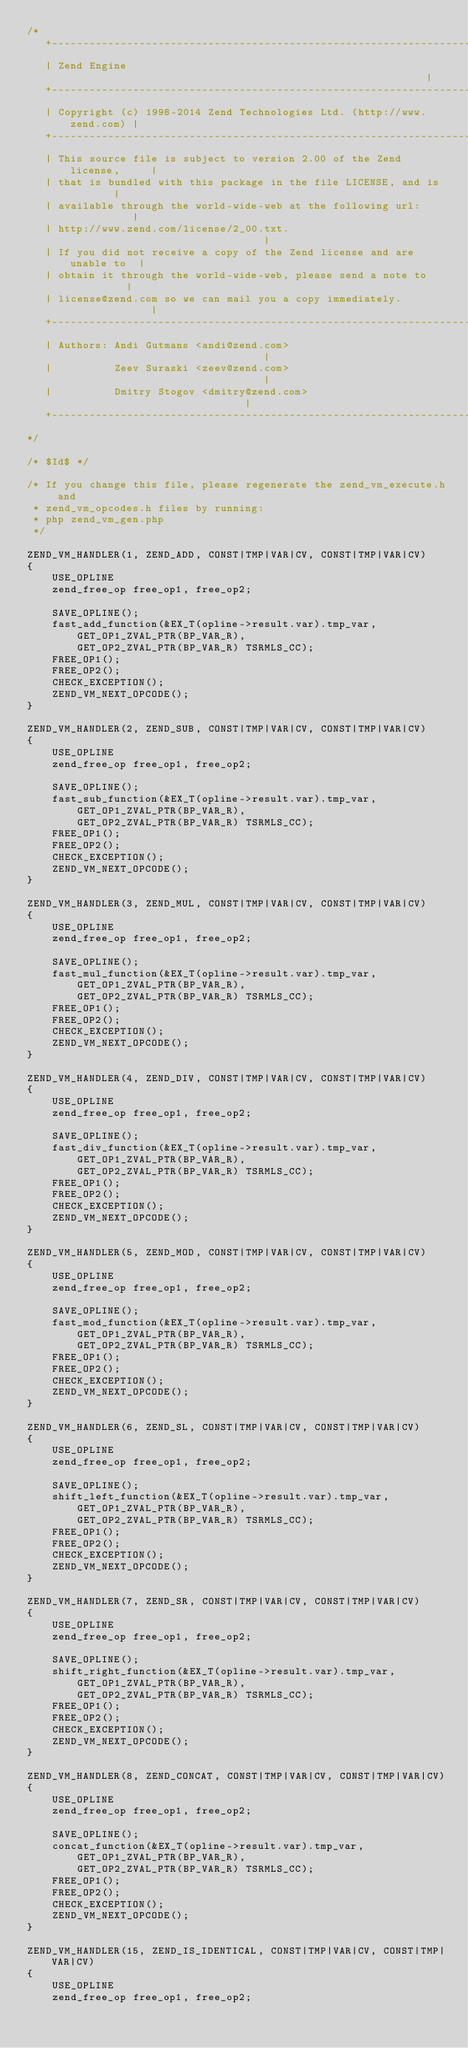<code> <loc_0><loc_0><loc_500><loc_500><_C_>/*
   +----------------------------------------------------------------------+
   | Zend Engine                                                          |
   +----------------------------------------------------------------------+
   | Copyright (c) 1998-2014 Zend Technologies Ltd. (http://www.zend.com) |
   +----------------------------------------------------------------------+
   | This source file is subject to version 2.00 of the Zend license,     |
   | that is bundled with this package in the file LICENSE, and is        |
   | available through the world-wide-web at the following url:           |
   | http://www.zend.com/license/2_00.txt.                                |
   | If you did not receive a copy of the Zend license and are unable to  |
   | obtain it through the world-wide-web, please send a note to          |
   | license@zend.com so we can mail you a copy immediately.              |
   +----------------------------------------------------------------------+
   | Authors: Andi Gutmans <andi@zend.com>                                |
   |          Zeev Suraski <zeev@zend.com>                                |
   |          Dmitry Stogov <dmitry@zend.com>                             |
   +----------------------------------------------------------------------+
*/

/* $Id$ */

/* If you change this file, please regenerate the zend_vm_execute.h and
 * zend_vm_opcodes.h files by running:
 * php zend_vm_gen.php
 */

ZEND_VM_HANDLER(1, ZEND_ADD, CONST|TMP|VAR|CV, CONST|TMP|VAR|CV)
{
	USE_OPLINE
	zend_free_op free_op1, free_op2;

	SAVE_OPLINE();
	fast_add_function(&EX_T(opline->result.var).tmp_var,
		GET_OP1_ZVAL_PTR(BP_VAR_R),
		GET_OP2_ZVAL_PTR(BP_VAR_R) TSRMLS_CC);
	FREE_OP1();
	FREE_OP2();
	CHECK_EXCEPTION();
	ZEND_VM_NEXT_OPCODE();
}

ZEND_VM_HANDLER(2, ZEND_SUB, CONST|TMP|VAR|CV, CONST|TMP|VAR|CV)
{
	USE_OPLINE
	zend_free_op free_op1, free_op2;

	SAVE_OPLINE();
	fast_sub_function(&EX_T(opline->result.var).tmp_var,
		GET_OP1_ZVAL_PTR(BP_VAR_R),
		GET_OP2_ZVAL_PTR(BP_VAR_R) TSRMLS_CC);
	FREE_OP1();
	FREE_OP2();
	CHECK_EXCEPTION();
	ZEND_VM_NEXT_OPCODE();
}

ZEND_VM_HANDLER(3, ZEND_MUL, CONST|TMP|VAR|CV, CONST|TMP|VAR|CV)
{
	USE_OPLINE
	zend_free_op free_op1, free_op2;

	SAVE_OPLINE();
	fast_mul_function(&EX_T(opline->result.var).tmp_var,
		GET_OP1_ZVAL_PTR(BP_VAR_R),
		GET_OP2_ZVAL_PTR(BP_VAR_R) TSRMLS_CC);
	FREE_OP1();
	FREE_OP2();
	CHECK_EXCEPTION();
	ZEND_VM_NEXT_OPCODE();
}

ZEND_VM_HANDLER(4, ZEND_DIV, CONST|TMP|VAR|CV, CONST|TMP|VAR|CV)
{
	USE_OPLINE
	zend_free_op free_op1, free_op2;

	SAVE_OPLINE();
	fast_div_function(&EX_T(opline->result.var).tmp_var,
		GET_OP1_ZVAL_PTR(BP_VAR_R),
		GET_OP2_ZVAL_PTR(BP_VAR_R) TSRMLS_CC);
	FREE_OP1();
	FREE_OP2();
	CHECK_EXCEPTION();
	ZEND_VM_NEXT_OPCODE();
}

ZEND_VM_HANDLER(5, ZEND_MOD, CONST|TMP|VAR|CV, CONST|TMP|VAR|CV)
{
	USE_OPLINE
	zend_free_op free_op1, free_op2;

	SAVE_OPLINE();
	fast_mod_function(&EX_T(opline->result.var).tmp_var,
		GET_OP1_ZVAL_PTR(BP_VAR_R),
		GET_OP2_ZVAL_PTR(BP_VAR_R) TSRMLS_CC);
	FREE_OP1();
	FREE_OP2();
	CHECK_EXCEPTION();
	ZEND_VM_NEXT_OPCODE();
}

ZEND_VM_HANDLER(6, ZEND_SL, CONST|TMP|VAR|CV, CONST|TMP|VAR|CV)
{
	USE_OPLINE
	zend_free_op free_op1, free_op2;

	SAVE_OPLINE();
	shift_left_function(&EX_T(opline->result.var).tmp_var,
		GET_OP1_ZVAL_PTR(BP_VAR_R),
		GET_OP2_ZVAL_PTR(BP_VAR_R) TSRMLS_CC);
	FREE_OP1();
	FREE_OP2();
	CHECK_EXCEPTION();
	ZEND_VM_NEXT_OPCODE();
}

ZEND_VM_HANDLER(7, ZEND_SR, CONST|TMP|VAR|CV, CONST|TMP|VAR|CV)
{
	USE_OPLINE
	zend_free_op free_op1, free_op2;

	SAVE_OPLINE();
	shift_right_function(&EX_T(opline->result.var).tmp_var,
		GET_OP1_ZVAL_PTR(BP_VAR_R),
		GET_OP2_ZVAL_PTR(BP_VAR_R) TSRMLS_CC);
	FREE_OP1();
	FREE_OP2();
	CHECK_EXCEPTION();
	ZEND_VM_NEXT_OPCODE();
}

ZEND_VM_HANDLER(8, ZEND_CONCAT, CONST|TMP|VAR|CV, CONST|TMP|VAR|CV)
{
	USE_OPLINE
	zend_free_op free_op1, free_op2;

	SAVE_OPLINE();
	concat_function(&EX_T(opline->result.var).tmp_var,
		GET_OP1_ZVAL_PTR(BP_VAR_R),
		GET_OP2_ZVAL_PTR(BP_VAR_R) TSRMLS_CC);
	FREE_OP1();
	FREE_OP2();
	CHECK_EXCEPTION();
	ZEND_VM_NEXT_OPCODE();
}

ZEND_VM_HANDLER(15, ZEND_IS_IDENTICAL, CONST|TMP|VAR|CV, CONST|TMP|VAR|CV)
{
	USE_OPLINE
	zend_free_op free_op1, free_op2;
</code> 